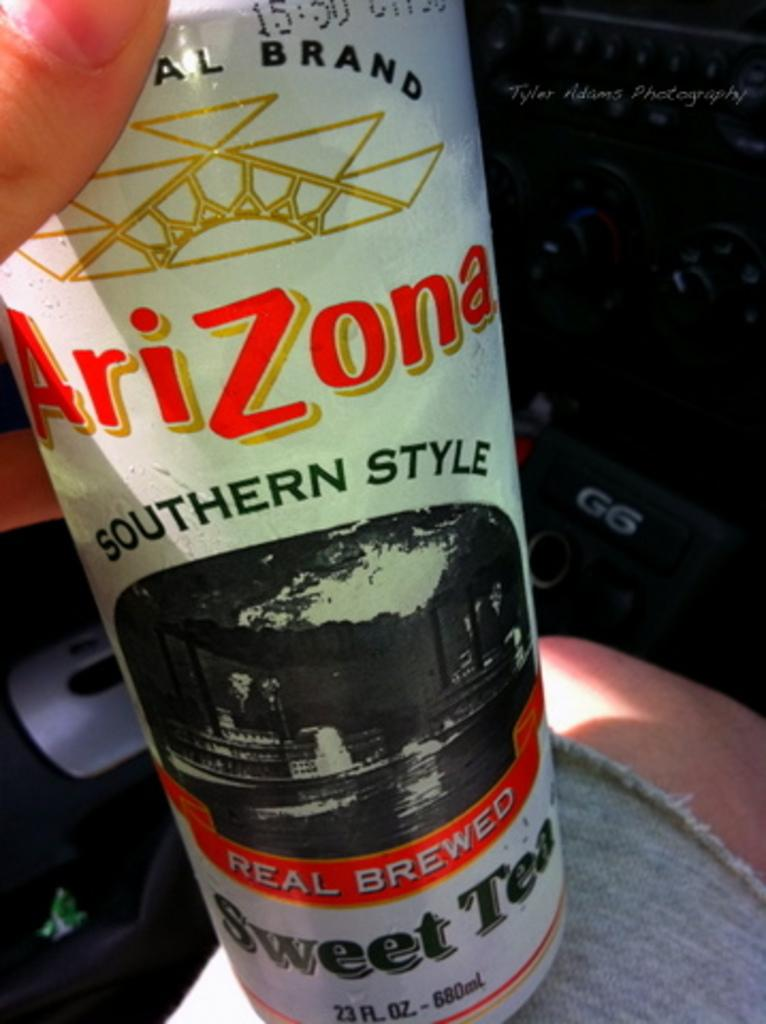<image>
Summarize the visual content of the image. a can of arizona southern style real brewed sweet tea 